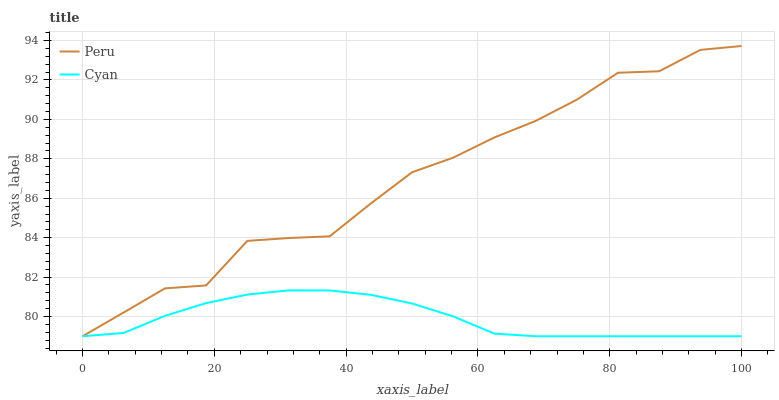Does Cyan have the minimum area under the curve?
Answer yes or no. Yes. Does Peru have the maximum area under the curve?
Answer yes or no. Yes. Does Peru have the minimum area under the curve?
Answer yes or no. No. Is Cyan the smoothest?
Answer yes or no. Yes. Is Peru the roughest?
Answer yes or no. Yes. Is Peru the smoothest?
Answer yes or no. No. Does Cyan have the lowest value?
Answer yes or no. Yes. Does Peru have the highest value?
Answer yes or no. Yes. Does Peru intersect Cyan?
Answer yes or no. Yes. Is Peru less than Cyan?
Answer yes or no. No. Is Peru greater than Cyan?
Answer yes or no. No. 